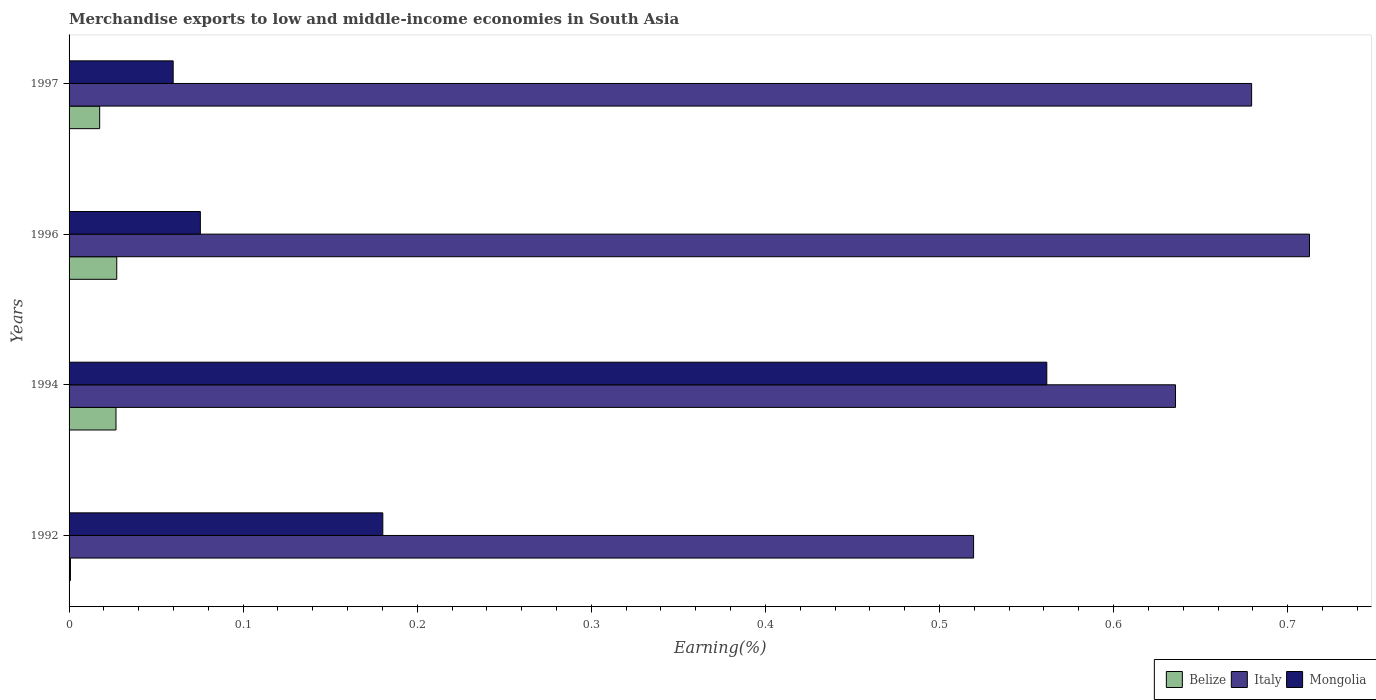How many groups of bars are there?
Provide a short and direct response. 4. Are the number of bars on each tick of the Y-axis equal?
Offer a terse response. Yes. What is the percentage of amount earned from merchandise exports in Belize in 1996?
Provide a succinct answer. 0.03. Across all years, what is the maximum percentage of amount earned from merchandise exports in Belize?
Offer a very short reply. 0.03. Across all years, what is the minimum percentage of amount earned from merchandise exports in Italy?
Offer a very short reply. 0.52. What is the total percentage of amount earned from merchandise exports in Mongolia in the graph?
Keep it short and to the point. 0.88. What is the difference between the percentage of amount earned from merchandise exports in Mongolia in 1992 and that in 1997?
Ensure brevity in your answer.  0.12. What is the difference between the percentage of amount earned from merchandise exports in Mongolia in 1996 and the percentage of amount earned from merchandise exports in Belize in 1997?
Provide a short and direct response. 0.06. What is the average percentage of amount earned from merchandise exports in Belize per year?
Your answer should be compact. 0.02. In the year 1992, what is the difference between the percentage of amount earned from merchandise exports in Italy and percentage of amount earned from merchandise exports in Belize?
Make the answer very short. 0.52. In how many years, is the percentage of amount earned from merchandise exports in Italy greater than 0.26 %?
Offer a very short reply. 4. What is the ratio of the percentage of amount earned from merchandise exports in Italy in 1992 to that in 1997?
Your answer should be compact. 0.76. What is the difference between the highest and the second highest percentage of amount earned from merchandise exports in Mongolia?
Offer a very short reply. 0.38. What is the difference between the highest and the lowest percentage of amount earned from merchandise exports in Belize?
Ensure brevity in your answer.  0.03. Is the sum of the percentage of amount earned from merchandise exports in Belize in 1994 and 1997 greater than the maximum percentage of amount earned from merchandise exports in Mongolia across all years?
Offer a terse response. No. What does the 1st bar from the top in 1994 represents?
Offer a terse response. Mongolia. What does the 3rd bar from the bottom in 1992 represents?
Make the answer very short. Mongolia. How many bars are there?
Your answer should be compact. 12. What is the difference between two consecutive major ticks on the X-axis?
Your response must be concise. 0.1. Are the values on the major ticks of X-axis written in scientific E-notation?
Your response must be concise. No. How are the legend labels stacked?
Give a very brief answer. Horizontal. What is the title of the graph?
Ensure brevity in your answer.  Merchandise exports to low and middle-income economies in South Asia. Does "Serbia" appear as one of the legend labels in the graph?
Make the answer very short. No. What is the label or title of the X-axis?
Your response must be concise. Earning(%). What is the Earning(%) in Belize in 1992?
Offer a terse response. 0. What is the Earning(%) in Italy in 1992?
Your answer should be compact. 0.52. What is the Earning(%) in Mongolia in 1992?
Give a very brief answer. 0.18. What is the Earning(%) in Belize in 1994?
Provide a short and direct response. 0.03. What is the Earning(%) of Italy in 1994?
Your answer should be compact. 0.64. What is the Earning(%) in Mongolia in 1994?
Make the answer very short. 0.56. What is the Earning(%) of Belize in 1996?
Your response must be concise. 0.03. What is the Earning(%) in Italy in 1996?
Your answer should be very brief. 0.71. What is the Earning(%) of Mongolia in 1996?
Offer a terse response. 0.08. What is the Earning(%) of Belize in 1997?
Offer a very short reply. 0.02. What is the Earning(%) in Italy in 1997?
Give a very brief answer. 0.68. What is the Earning(%) in Mongolia in 1997?
Ensure brevity in your answer.  0.06. Across all years, what is the maximum Earning(%) of Belize?
Your answer should be very brief. 0.03. Across all years, what is the maximum Earning(%) in Italy?
Offer a very short reply. 0.71. Across all years, what is the maximum Earning(%) in Mongolia?
Ensure brevity in your answer.  0.56. Across all years, what is the minimum Earning(%) in Belize?
Provide a succinct answer. 0. Across all years, what is the minimum Earning(%) of Italy?
Keep it short and to the point. 0.52. Across all years, what is the minimum Earning(%) of Mongolia?
Your answer should be compact. 0.06. What is the total Earning(%) in Belize in the graph?
Offer a terse response. 0.07. What is the total Earning(%) in Italy in the graph?
Your answer should be compact. 2.55. What is the total Earning(%) of Mongolia in the graph?
Offer a very short reply. 0.88. What is the difference between the Earning(%) of Belize in 1992 and that in 1994?
Offer a very short reply. -0.03. What is the difference between the Earning(%) of Italy in 1992 and that in 1994?
Provide a short and direct response. -0.12. What is the difference between the Earning(%) in Mongolia in 1992 and that in 1994?
Your answer should be compact. -0.38. What is the difference between the Earning(%) in Belize in 1992 and that in 1996?
Give a very brief answer. -0.03. What is the difference between the Earning(%) of Italy in 1992 and that in 1996?
Ensure brevity in your answer.  -0.19. What is the difference between the Earning(%) of Mongolia in 1992 and that in 1996?
Your answer should be very brief. 0.1. What is the difference between the Earning(%) of Belize in 1992 and that in 1997?
Provide a short and direct response. -0.02. What is the difference between the Earning(%) in Italy in 1992 and that in 1997?
Offer a very short reply. -0.16. What is the difference between the Earning(%) of Mongolia in 1992 and that in 1997?
Your answer should be very brief. 0.12. What is the difference between the Earning(%) in Belize in 1994 and that in 1996?
Your answer should be compact. -0. What is the difference between the Earning(%) in Italy in 1994 and that in 1996?
Your response must be concise. -0.08. What is the difference between the Earning(%) of Mongolia in 1994 and that in 1996?
Ensure brevity in your answer.  0.49. What is the difference between the Earning(%) in Belize in 1994 and that in 1997?
Your answer should be compact. 0.01. What is the difference between the Earning(%) of Italy in 1994 and that in 1997?
Keep it short and to the point. -0.04. What is the difference between the Earning(%) in Mongolia in 1994 and that in 1997?
Make the answer very short. 0.5. What is the difference between the Earning(%) in Belize in 1996 and that in 1997?
Ensure brevity in your answer.  0.01. What is the difference between the Earning(%) of Italy in 1996 and that in 1997?
Ensure brevity in your answer.  0.03. What is the difference between the Earning(%) in Mongolia in 1996 and that in 1997?
Provide a short and direct response. 0.02. What is the difference between the Earning(%) in Belize in 1992 and the Earning(%) in Italy in 1994?
Your answer should be very brief. -0.63. What is the difference between the Earning(%) in Belize in 1992 and the Earning(%) in Mongolia in 1994?
Offer a very short reply. -0.56. What is the difference between the Earning(%) in Italy in 1992 and the Earning(%) in Mongolia in 1994?
Offer a very short reply. -0.04. What is the difference between the Earning(%) in Belize in 1992 and the Earning(%) in Italy in 1996?
Your answer should be compact. -0.71. What is the difference between the Earning(%) of Belize in 1992 and the Earning(%) of Mongolia in 1996?
Your response must be concise. -0.07. What is the difference between the Earning(%) in Italy in 1992 and the Earning(%) in Mongolia in 1996?
Provide a short and direct response. 0.44. What is the difference between the Earning(%) of Belize in 1992 and the Earning(%) of Italy in 1997?
Keep it short and to the point. -0.68. What is the difference between the Earning(%) of Belize in 1992 and the Earning(%) of Mongolia in 1997?
Your response must be concise. -0.06. What is the difference between the Earning(%) of Italy in 1992 and the Earning(%) of Mongolia in 1997?
Provide a short and direct response. 0.46. What is the difference between the Earning(%) of Belize in 1994 and the Earning(%) of Italy in 1996?
Give a very brief answer. -0.69. What is the difference between the Earning(%) in Belize in 1994 and the Earning(%) in Mongolia in 1996?
Offer a terse response. -0.05. What is the difference between the Earning(%) of Italy in 1994 and the Earning(%) of Mongolia in 1996?
Your answer should be compact. 0.56. What is the difference between the Earning(%) of Belize in 1994 and the Earning(%) of Italy in 1997?
Provide a succinct answer. -0.65. What is the difference between the Earning(%) of Belize in 1994 and the Earning(%) of Mongolia in 1997?
Give a very brief answer. -0.03. What is the difference between the Earning(%) in Italy in 1994 and the Earning(%) in Mongolia in 1997?
Provide a succinct answer. 0.58. What is the difference between the Earning(%) in Belize in 1996 and the Earning(%) in Italy in 1997?
Your answer should be very brief. -0.65. What is the difference between the Earning(%) in Belize in 1996 and the Earning(%) in Mongolia in 1997?
Your response must be concise. -0.03. What is the difference between the Earning(%) of Italy in 1996 and the Earning(%) of Mongolia in 1997?
Make the answer very short. 0.65. What is the average Earning(%) of Belize per year?
Provide a succinct answer. 0.02. What is the average Earning(%) of Italy per year?
Give a very brief answer. 0.64. What is the average Earning(%) in Mongolia per year?
Your response must be concise. 0.22. In the year 1992, what is the difference between the Earning(%) in Belize and Earning(%) in Italy?
Provide a succinct answer. -0.52. In the year 1992, what is the difference between the Earning(%) in Belize and Earning(%) in Mongolia?
Make the answer very short. -0.18. In the year 1992, what is the difference between the Earning(%) in Italy and Earning(%) in Mongolia?
Your answer should be very brief. 0.34. In the year 1994, what is the difference between the Earning(%) of Belize and Earning(%) of Italy?
Offer a terse response. -0.61. In the year 1994, what is the difference between the Earning(%) of Belize and Earning(%) of Mongolia?
Your answer should be compact. -0.53. In the year 1994, what is the difference between the Earning(%) of Italy and Earning(%) of Mongolia?
Make the answer very short. 0.07. In the year 1996, what is the difference between the Earning(%) in Belize and Earning(%) in Italy?
Your answer should be very brief. -0.69. In the year 1996, what is the difference between the Earning(%) in Belize and Earning(%) in Mongolia?
Your answer should be compact. -0.05. In the year 1996, what is the difference between the Earning(%) in Italy and Earning(%) in Mongolia?
Ensure brevity in your answer.  0.64. In the year 1997, what is the difference between the Earning(%) of Belize and Earning(%) of Italy?
Your response must be concise. -0.66. In the year 1997, what is the difference between the Earning(%) of Belize and Earning(%) of Mongolia?
Your answer should be compact. -0.04. In the year 1997, what is the difference between the Earning(%) in Italy and Earning(%) in Mongolia?
Your answer should be compact. 0.62. What is the ratio of the Earning(%) in Belize in 1992 to that in 1994?
Ensure brevity in your answer.  0.03. What is the ratio of the Earning(%) of Italy in 1992 to that in 1994?
Provide a succinct answer. 0.82. What is the ratio of the Earning(%) of Mongolia in 1992 to that in 1994?
Your response must be concise. 0.32. What is the ratio of the Earning(%) of Belize in 1992 to that in 1996?
Provide a succinct answer. 0.03. What is the ratio of the Earning(%) in Italy in 1992 to that in 1996?
Make the answer very short. 0.73. What is the ratio of the Earning(%) in Mongolia in 1992 to that in 1996?
Give a very brief answer. 2.39. What is the ratio of the Earning(%) in Belize in 1992 to that in 1997?
Provide a succinct answer. 0.05. What is the ratio of the Earning(%) of Italy in 1992 to that in 1997?
Keep it short and to the point. 0.76. What is the ratio of the Earning(%) in Mongolia in 1992 to that in 1997?
Keep it short and to the point. 3.01. What is the ratio of the Earning(%) in Belize in 1994 to that in 1996?
Offer a terse response. 0.98. What is the ratio of the Earning(%) in Italy in 1994 to that in 1996?
Offer a terse response. 0.89. What is the ratio of the Earning(%) in Mongolia in 1994 to that in 1996?
Your answer should be very brief. 7.45. What is the ratio of the Earning(%) in Belize in 1994 to that in 1997?
Make the answer very short. 1.53. What is the ratio of the Earning(%) in Italy in 1994 to that in 1997?
Your answer should be very brief. 0.94. What is the ratio of the Earning(%) in Mongolia in 1994 to that in 1997?
Provide a short and direct response. 9.39. What is the ratio of the Earning(%) in Belize in 1996 to that in 1997?
Provide a short and direct response. 1.56. What is the ratio of the Earning(%) of Italy in 1996 to that in 1997?
Your answer should be very brief. 1.05. What is the ratio of the Earning(%) of Mongolia in 1996 to that in 1997?
Your answer should be compact. 1.26. What is the difference between the highest and the second highest Earning(%) of Italy?
Make the answer very short. 0.03. What is the difference between the highest and the second highest Earning(%) of Mongolia?
Keep it short and to the point. 0.38. What is the difference between the highest and the lowest Earning(%) of Belize?
Provide a succinct answer. 0.03. What is the difference between the highest and the lowest Earning(%) in Italy?
Make the answer very short. 0.19. What is the difference between the highest and the lowest Earning(%) of Mongolia?
Your answer should be very brief. 0.5. 